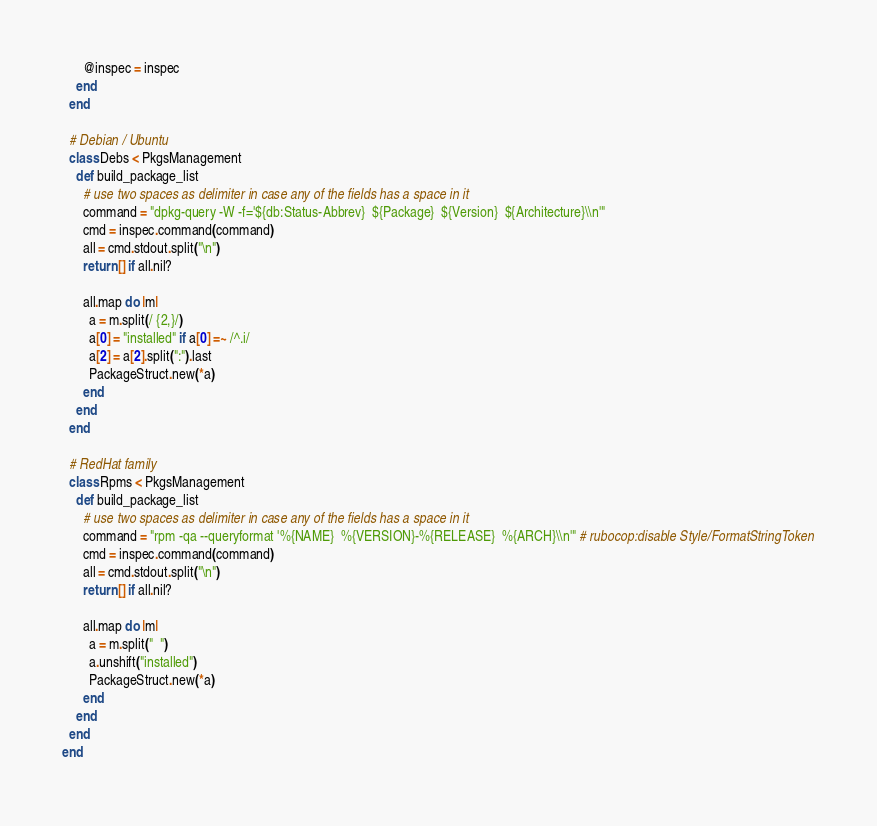<code> <loc_0><loc_0><loc_500><loc_500><_Ruby_>      @inspec = inspec
    end
  end

  # Debian / Ubuntu
  class Debs < PkgsManagement
    def build_package_list
      # use two spaces as delimiter in case any of the fields has a space in it
      command = "dpkg-query -W -f='${db:Status-Abbrev}  ${Package}  ${Version}  ${Architecture}\\n'"
      cmd = inspec.command(command)
      all = cmd.stdout.split("\n")
      return [] if all.nil?

      all.map do |m|
        a = m.split(/ {2,}/)
        a[0] = "installed" if a[0] =~ /^.i/
        a[2] = a[2].split(":").last
        PackageStruct.new(*a)
      end
    end
  end

  # RedHat family
  class Rpms < PkgsManagement
    def build_package_list
      # use two spaces as delimiter in case any of the fields has a space in it
      command = "rpm -qa --queryformat '%{NAME}  %{VERSION}-%{RELEASE}  %{ARCH}\\n'" # rubocop:disable Style/FormatStringToken
      cmd = inspec.command(command)
      all = cmd.stdout.split("\n")
      return [] if all.nil?

      all.map do |m|
        a = m.split("  ")
        a.unshift("installed")
        PackageStruct.new(*a)
      end
    end
  end
end
</code> 